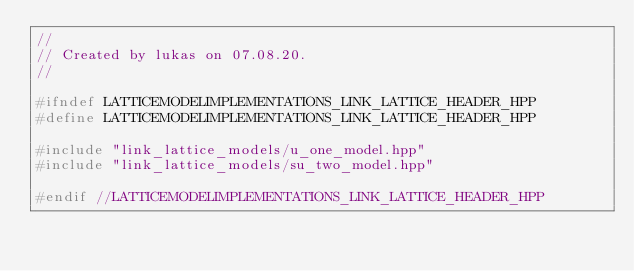<code> <loc_0><loc_0><loc_500><loc_500><_C++_>//
// Created by lukas on 07.08.20.
//

#ifndef LATTICEMODELIMPLEMENTATIONS_LINK_LATTICE_HEADER_HPP
#define LATTICEMODELIMPLEMENTATIONS_LINK_LATTICE_HEADER_HPP

#include "link_lattice_models/u_one_model.hpp"
#include "link_lattice_models/su_two_model.hpp"

#endif //LATTICEMODELIMPLEMENTATIONS_LINK_LATTICE_HEADER_HPP
</code> 